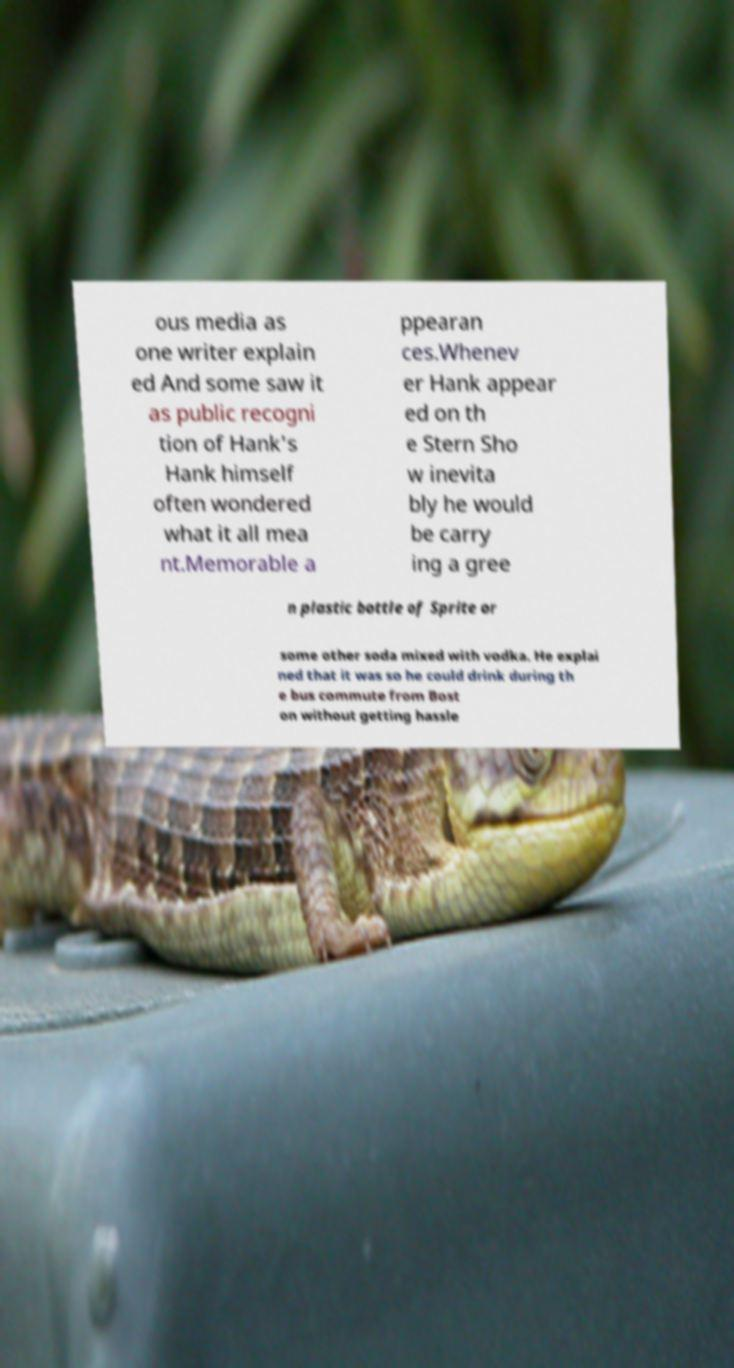For documentation purposes, I need the text within this image transcribed. Could you provide that? ous media as one writer explain ed And some saw it as public recogni tion of Hank's Hank himself often wondered what it all mea nt.Memorable a ppearan ces.Whenev er Hank appear ed on th e Stern Sho w inevita bly he would be carry ing a gree n plastic bottle of Sprite or some other soda mixed with vodka. He explai ned that it was so he could drink during th e bus commute from Bost on without getting hassle 